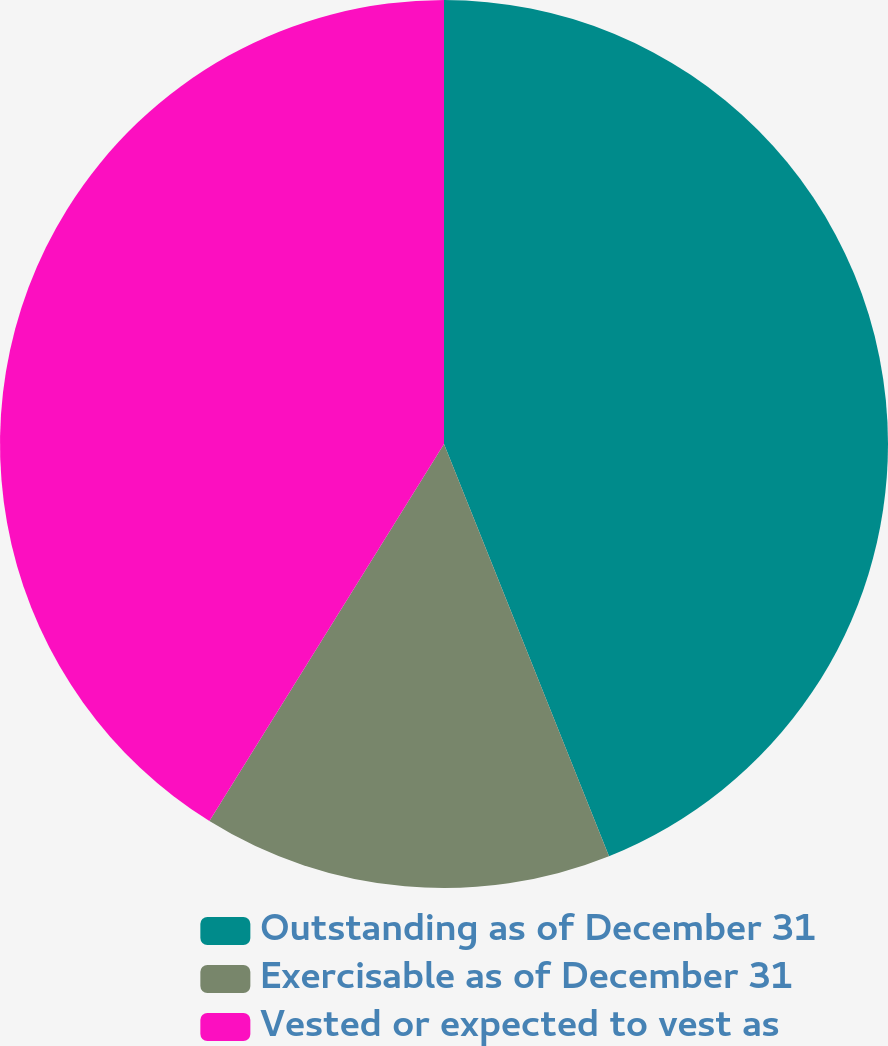Convert chart. <chart><loc_0><loc_0><loc_500><loc_500><pie_chart><fcel>Outstanding as of December 31<fcel>Exercisable as of December 31<fcel>Vested or expected to vest as<nl><fcel>43.94%<fcel>14.92%<fcel>41.14%<nl></chart> 